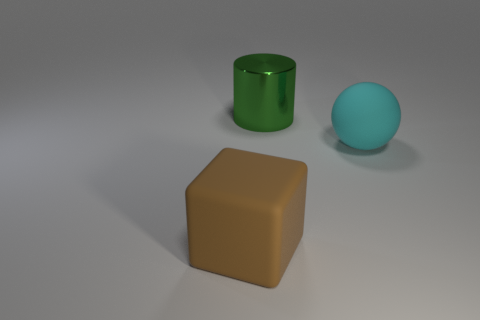Add 1 large cylinders. How many objects exist? 4 Subtract all cylinders. How many objects are left? 2 Subtract all big things. Subtract all tiny purple rubber spheres. How many objects are left? 0 Add 2 big rubber cubes. How many big rubber cubes are left? 3 Add 2 matte spheres. How many matte spheres exist? 3 Subtract 0 blue cubes. How many objects are left? 3 